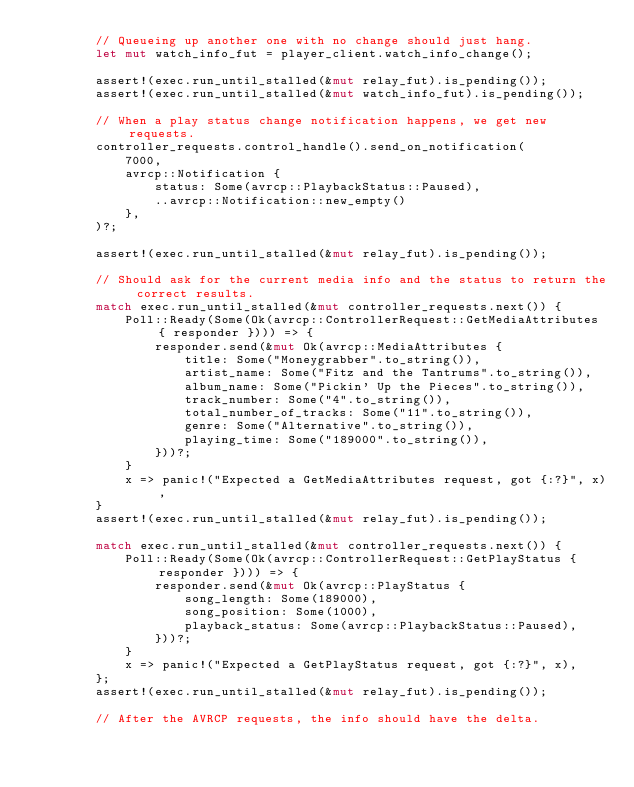Convert code to text. <code><loc_0><loc_0><loc_500><loc_500><_Rust_>        // Queueing up another one with no change should just hang.
        let mut watch_info_fut = player_client.watch_info_change();

        assert!(exec.run_until_stalled(&mut relay_fut).is_pending());
        assert!(exec.run_until_stalled(&mut watch_info_fut).is_pending());

        // When a play status change notification happens, we get new requests.
        controller_requests.control_handle().send_on_notification(
            7000,
            avrcp::Notification {
                status: Some(avrcp::PlaybackStatus::Paused),
                ..avrcp::Notification::new_empty()
            },
        )?;

        assert!(exec.run_until_stalled(&mut relay_fut).is_pending());

        // Should ask for the current media info and the status to return the correct results.
        match exec.run_until_stalled(&mut controller_requests.next()) {
            Poll::Ready(Some(Ok(avrcp::ControllerRequest::GetMediaAttributes { responder }))) => {
                responder.send(&mut Ok(avrcp::MediaAttributes {
                    title: Some("Moneygrabber".to_string()),
                    artist_name: Some("Fitz and the Tantrums".to_string()),
                    album_name: Some("Pickin' Up the Pieces".to_string()),
                    track_number: Some("4".to_string()),
                    total_number_of_tracks: Some("11".to_string()),
                    genre: Some("Alternative".to_string()),
                    playing_time: Some("189000".to_string()),
                }))?;
            }
            x => panic!("Expected a GetMediaAttributes request, got {:?}", x),
        }
        assert!(exec.run_until_stalled(&mut relay_fut).is_pending());

        match exec.run_until_stalled(&mut controller_requests.next()) {
            Poll::Ready(Some(Ok(avrcp::ControllerRequest::GetPlayStatus { responder }))) => {
                responder.send(&mut Ok(avrcp::PlayStatus {
                    song_length: Some(189000),
                    song_position: Some(1000),
                    playback_status: Some(avrcp::PlaybackStatus::Paused),
                }))?;
            }
            x => panic!("Expected a GetPlayStatus request, got {:?}", x),
        };
        assert!(exec.run_until_stalled(&mut relay_fut).is_pending());

        // After the AVRCP requests, the info should have the delta.</code> 